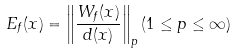<formula> <loc_0><loc_0><loc_500><loc_500>E _ { f } ( x ) = \left \| \frac { W _ { f } ( x ) } { d ( x ) } \right \| _ { p } ( 1 \leq p \leq \infty )</formula> 